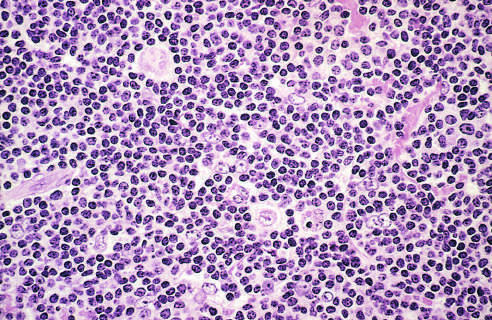what do numerous mature-looking lymphocytes surround?
Answer the question using a single word or phrase. Scattered 